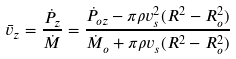Convert formula to latex. <formula><loc_0><loc_0><loc_500><loc_500>\bar { v } _ { z } = \frac { \dot { P } _ { z } } { \dot { M } } = \frac { \dot { P } _ { o z } - \pi \rho v _ { s } ^ { 2 } ( R ^ { 2 } - R _ { o } ^ { 2 } ) } { \dot { M } _ { o } + \pi \rho v _ { s } ( R ^ { 2 } - R _ { o } ^ { 2 } ) }</formula> 